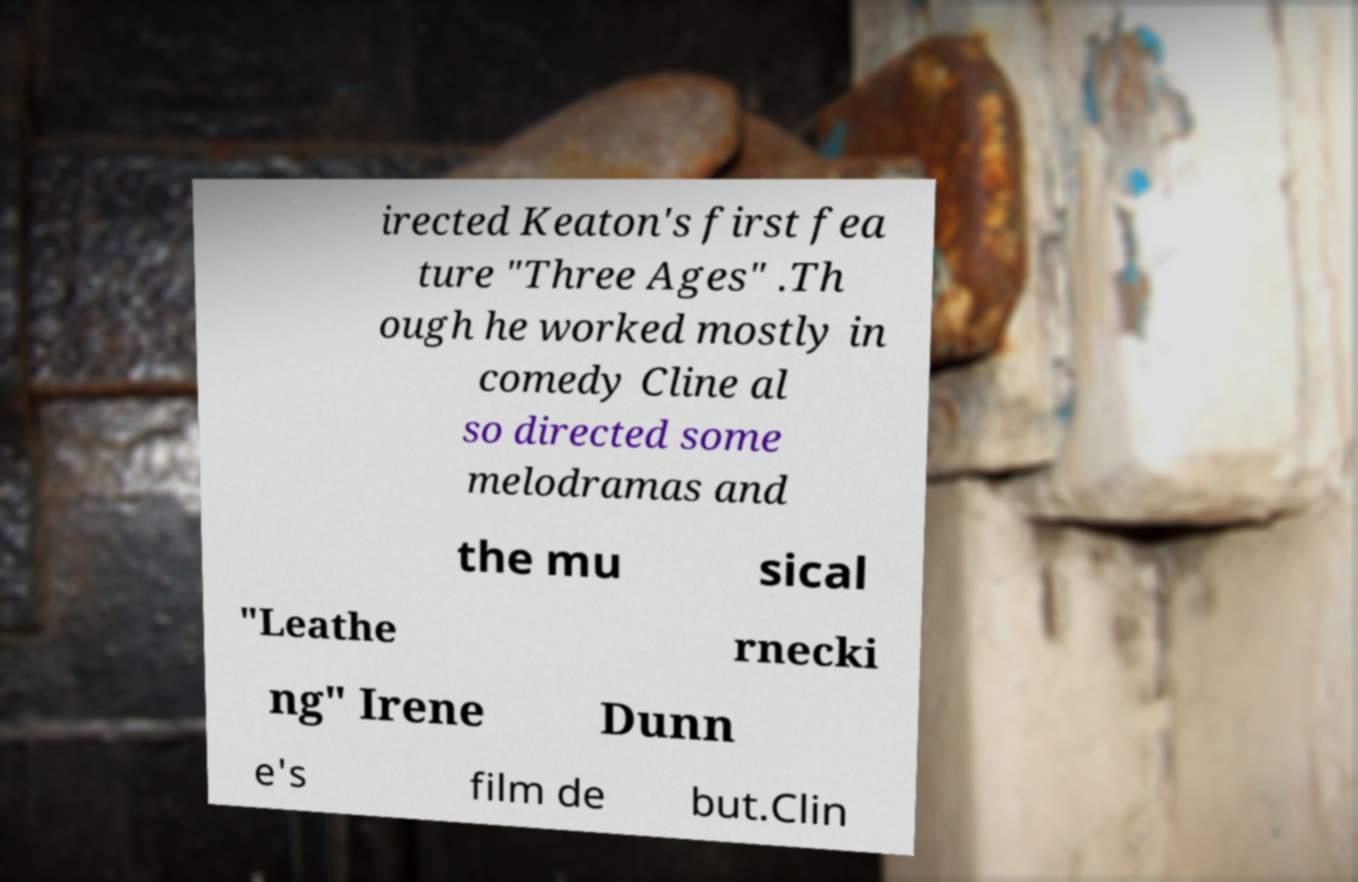Please identify and transcribe the text found in this image. irected Keaton's first fea ture "Three Ages" .Th ough he worked mostly in comedy Cline al so directed some melodramas and the mu sical "Leathe rnecki ng" Irene Dunn e's film de but.Clin 